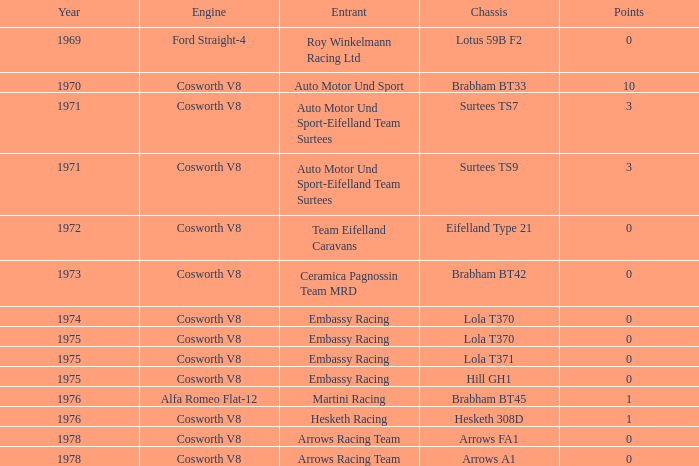Parse the table in full. {'header': ['Year', 'Engine', 'Entrant', 'Chassis', 'Points'], 'rows': [['1969', 'Ford Straight-4', 'Roy Winkelmann Racing Ltd', 'Lotus 59B F2', '0'], ['1970', 'Cosworth V8', 'Auto Motor Und Sport', 'Brabham BT33', '10'], ['1971', 'Cosworth V8', 'Auto Motor Und Sport-Eifelland Team Surtees', 'Surtees TS7', '3'], ['1971', 'Cosworth V8', 'Auto Motor Und Sport-Eifelland Team Surtees', 'Surtees TS9', '3'], ['1972', 'Cosworth V8', 'Team Eifelland Caravans', 'Eifelland Type 21', '0'], ['1973', 'Cosworth V8', 'Ceramica Pagnossin Team MRD', 'Brabham BT42', '0'], ['1974', 'Cosworth V8', 'Embassy Racing', 'Lola T370', '0'], ['1975', 'Cosworth V8', 'Embassy Racing', 'Lola T370', '0'], ['1975', 'Cosworth V8', 'Embassy Racing', 'Lola T371', '0'], ['1975', 'Cosworth V8', 'Embassy Racing', 'Hill GH1', '0'], ['1976', 'Alfa Romeo Flat-12', 'Martini Racing', 'Brabham BT45', '1'], ['1976', 'Cosworth V8', 'Hesketh Racing', 'Hesketh 308D', '1'], ['1978', 'Cosworth V8', 'Arrows Racing Team', 'Arrows FA1', '0'], ['1978', 'Cosworth V8', 'Arrows Racing Team', 'Arrows A1', '0']]} In 1970, what entrant had a cosworth v8 engine? Auto Motor Und Sport. 